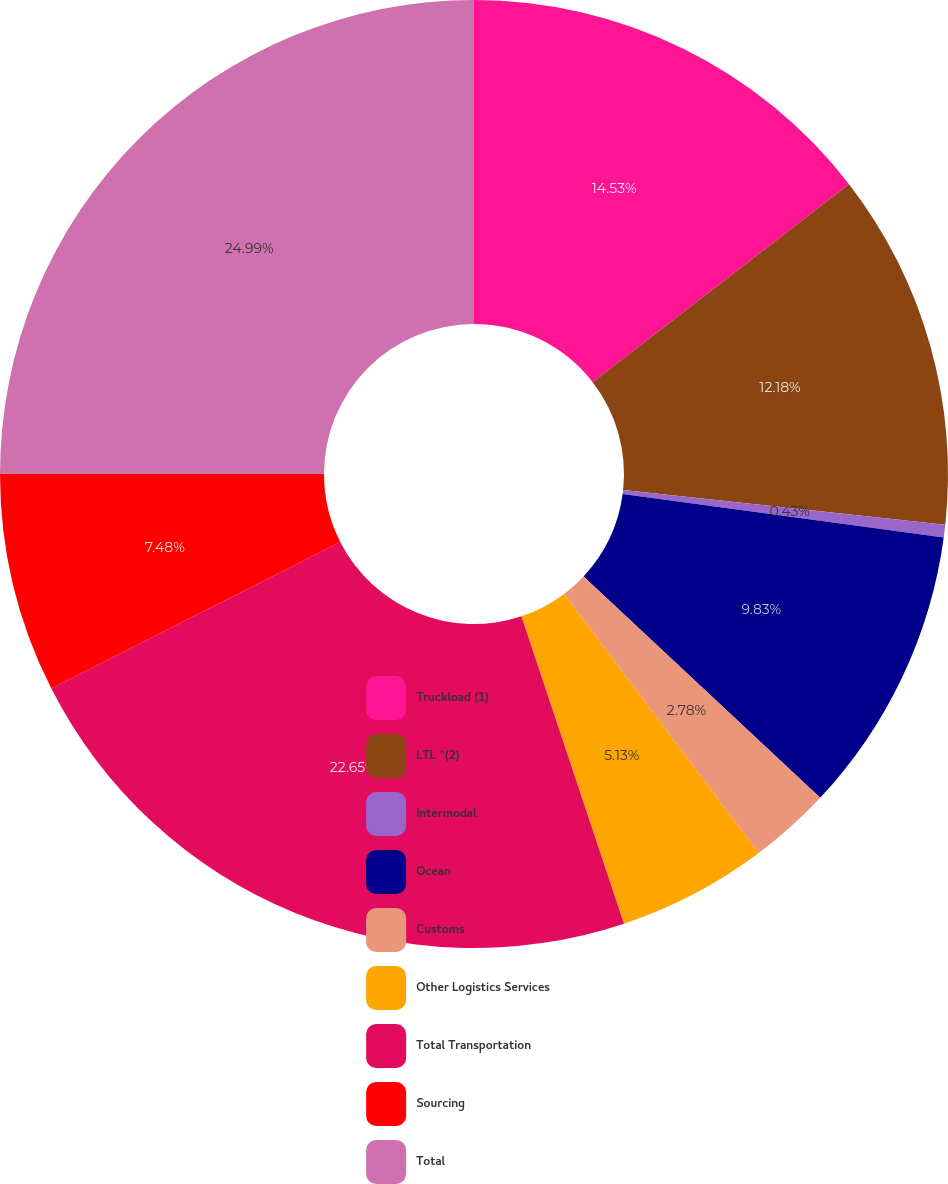<chart> <loc_0><loc_0><loc_500><loc_500><pie_chart><fcel>Truckload (1)<fcel>LTL ^(2)<fcel>Intermodal<fcel>Ocean<fcel>Customs<fcel>Other Logistics Services<fcel>Total Transportation<fcel>Sourcing<fcel>Total<nl><fcel>14.53%<fcel>12.18%<fcel>0.43%<fcel>9.83%<fcel>2.78%<fcel>5.13%<fcel>22.65%<fcel>7.48%<fcel>25.0%<nl></chart> 